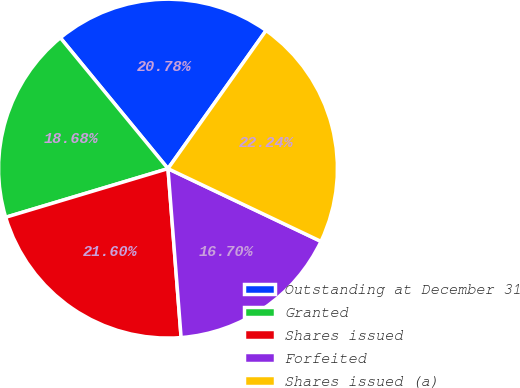<chart> <loc_0><loc_0><loc_500><loc_500><pie_chart><fcel>Outstanding at December 31<fcel>Granted<fcel>Shares issued<fcel>Forfeited<fcel>Shares issued (a)<nl><fcel>20.78%<fcel>18.68%<fcel>21.6%<fcel>16.7%<fcel>22.24%<nl></chart> 